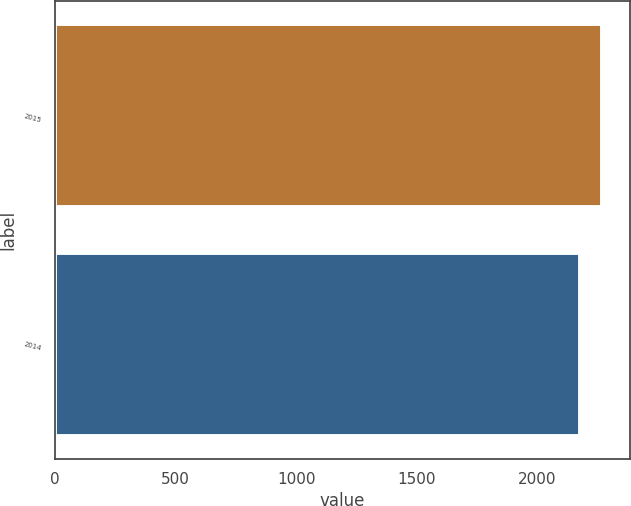Convert chart to OTSL. <chart><loc_0><loc_0><loc_500><loc_500><bar_chart><fcel>2015<fcel>2014<nl><fcel>2270<fcel>2179<nl></chart> 